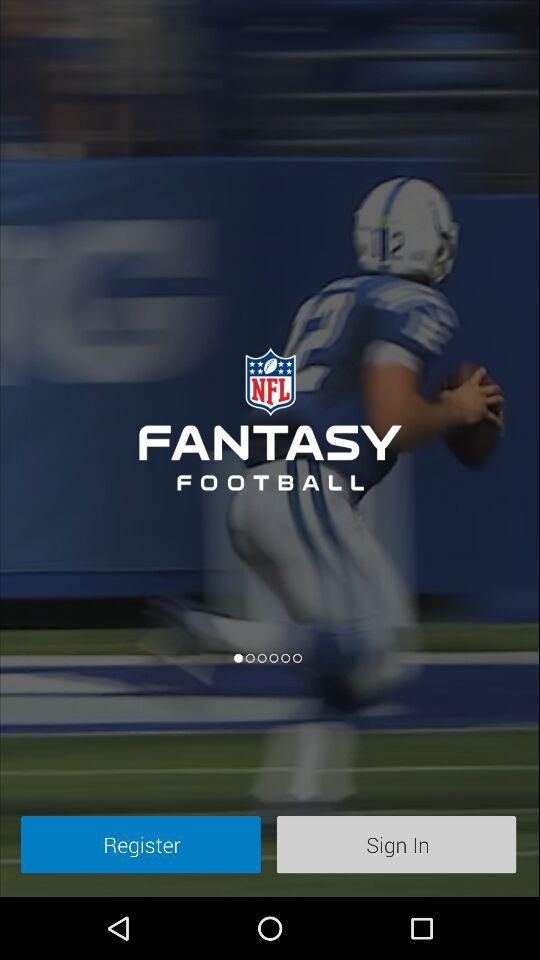What is the name of the application? The name of the application is "FANTASY FOOTBALL". 